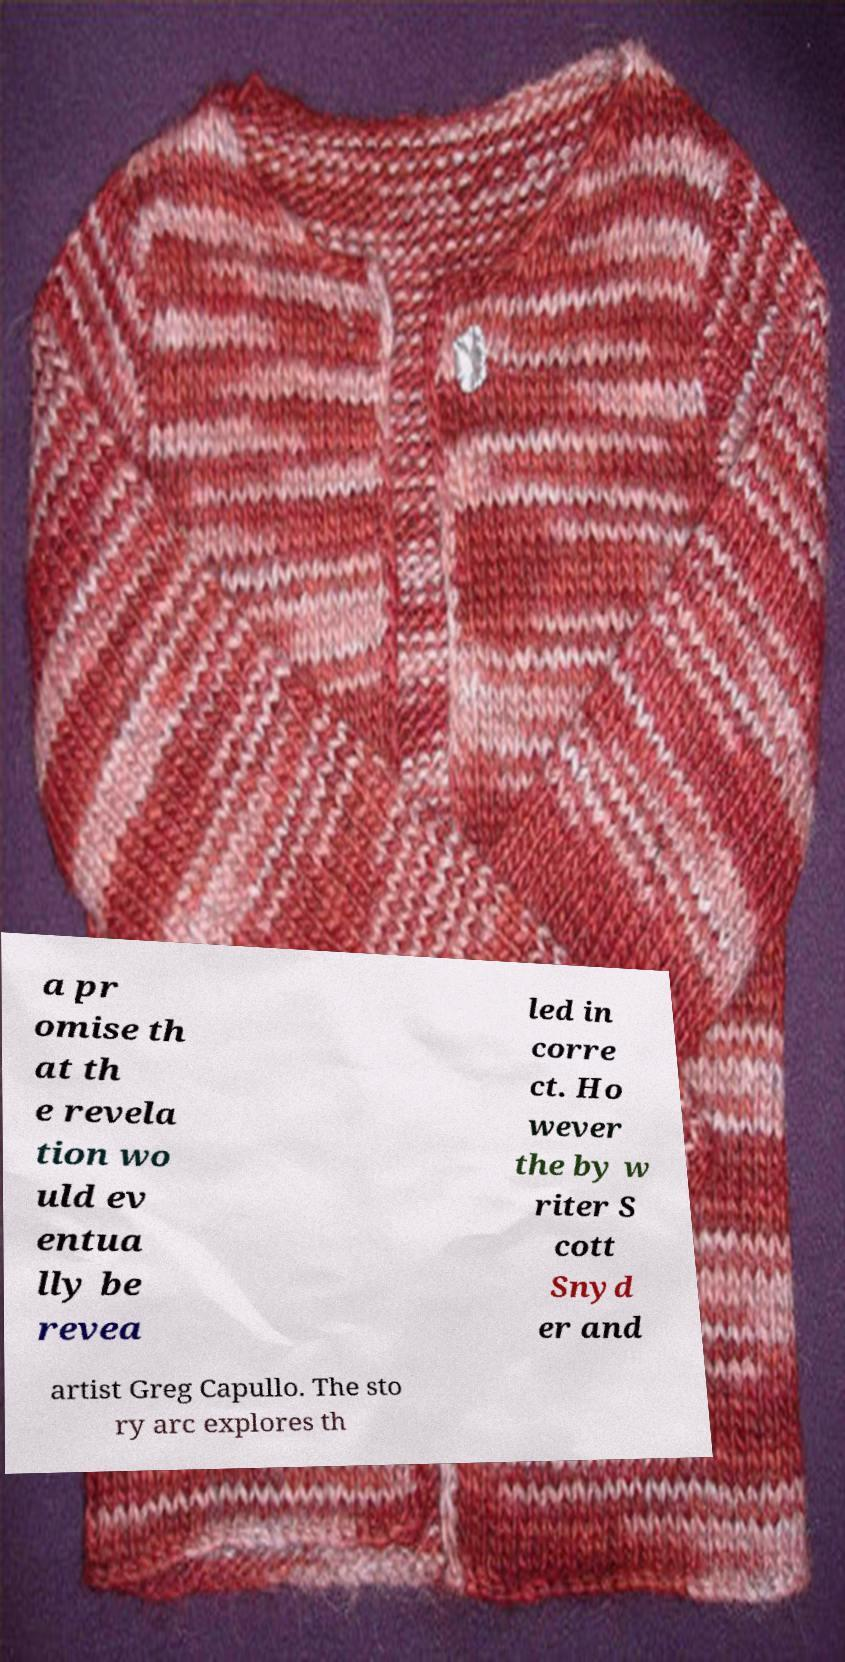Please read and relay the text visible in this image. What does it say? a pr omise th at th e revela tion wo uld ev entua lly be revea led in corre ct. Ho wever the by w riter S cott Snyd er and artist Greg Capullo. The sto ry arc explores th 